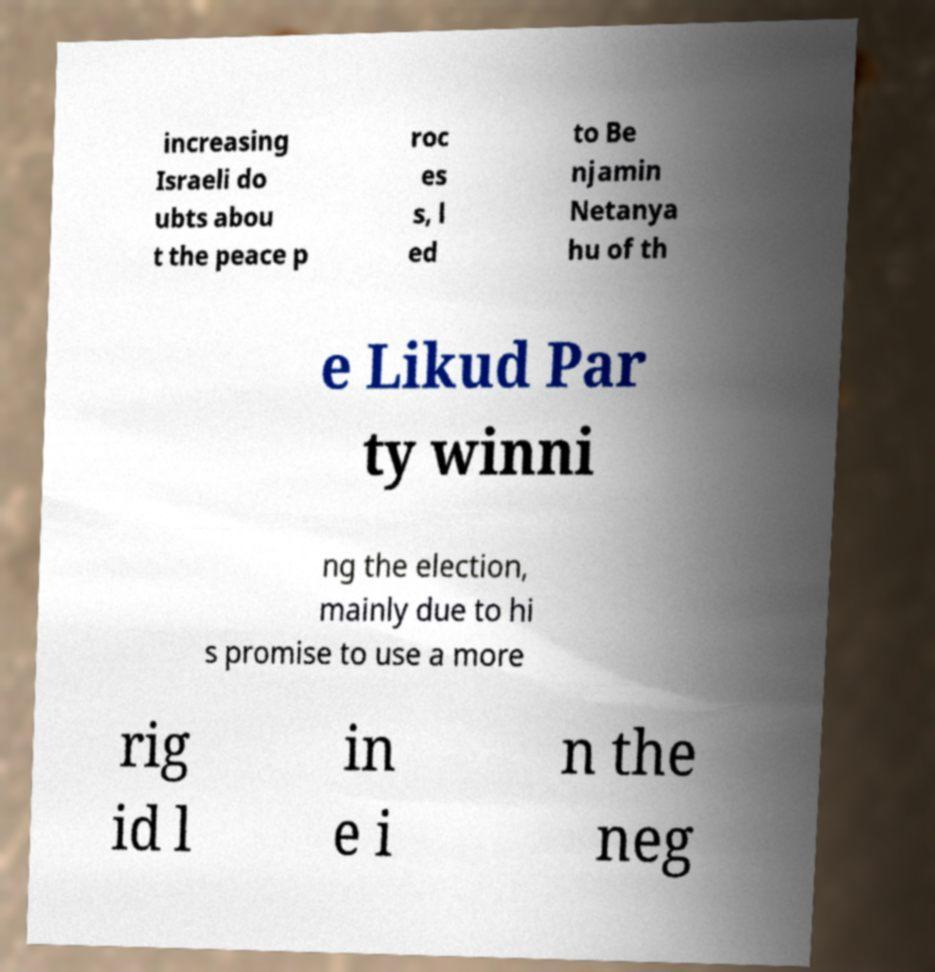Could you assist in decoding the text presented in this image and type it out clearly? increasing Israeli do ubts abou t the peace p roc es s, l ed to Be njamin Netanya hu of th e Likud Par ty winni ng the election, mainly due to hi s promise to use a more rig id l in e i n the neg 